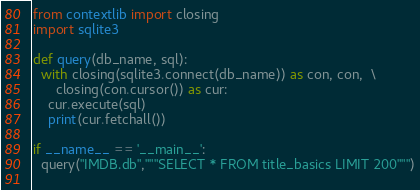Convert code to text. <code><loc_0><loc_0><loc_500><loc_500><_Python_>from contextlib import closing
import sqlite3

def query(db_name, sql):
  with closing(sqlite3.connect(db_name)) as con, con,  \
      closing(con.cursor()) as cur:
    cur.execute(sql)
    print(cur.fetchall())    

if __name__ == '__main__':
  query("IMDB.db","""SELECT * FROM title_basics LIMIT 200""")
 
</code> 